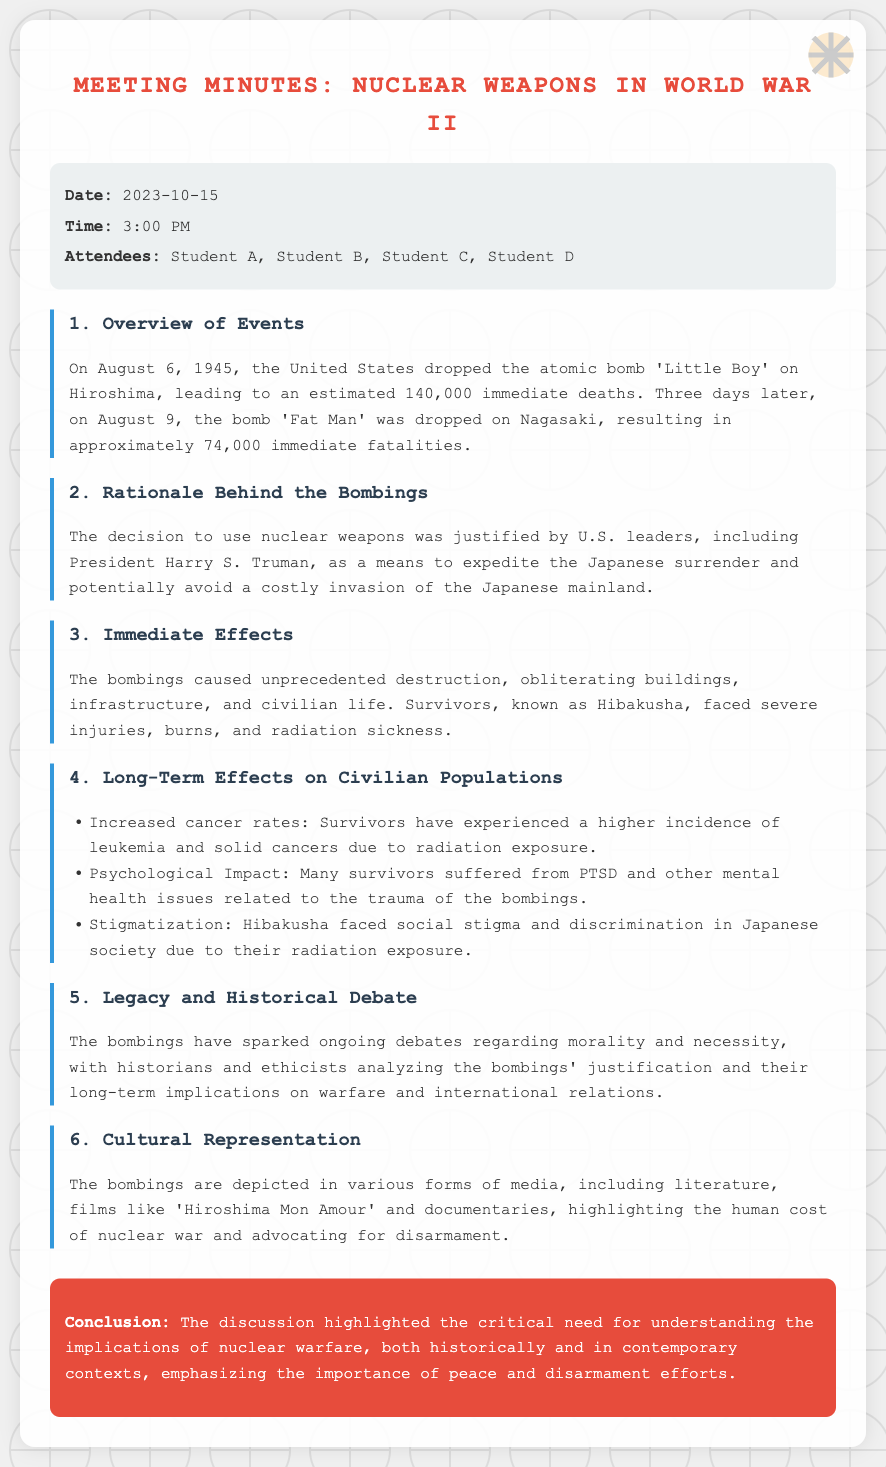What date was the meeting held? The meeting was held on October 15, 2023, as stated in the document.
Answer: October 15, 2023 How many immediate deaths resulted from the bombing of Hiroshima? The document states that there were an estimated 140,000 immediate deaths due to the Hiroshima bombing.
Answer: 140,000 What was the name of the bomb dropped on Nagasaki? According to the minutes, the bomb dropped on Nagasaki was called 'Fat Man'.
Answer: Fat Man What was one psychological effect on survivors? The document mentions that many survivors suffered from PTSD and other mental health issues, indicating psychological impacts.
Answer: PTSD What justification was provided for using nuclear weapons? The rationale behind the bombings was to expedite the Japanese surrender and possibly avoid a costly invasion.
Answer: Expedite surrender What is the term used for survivors of the bombings? The document refers to survivors of the atomic bombings as Hibakusha.
Answer: Hibakusha What long-term health issue increased among survivors? Increased cancer rates is mentioned as a long-term health issue affecting survivors.
Answer: Increased cancer rates Which cultural medium depicts the bombings? The document highlights literature and films, mentioning 'Hiroshima Mon Amour' as a specific example.
Answer: Hiroshima Mon Amour 